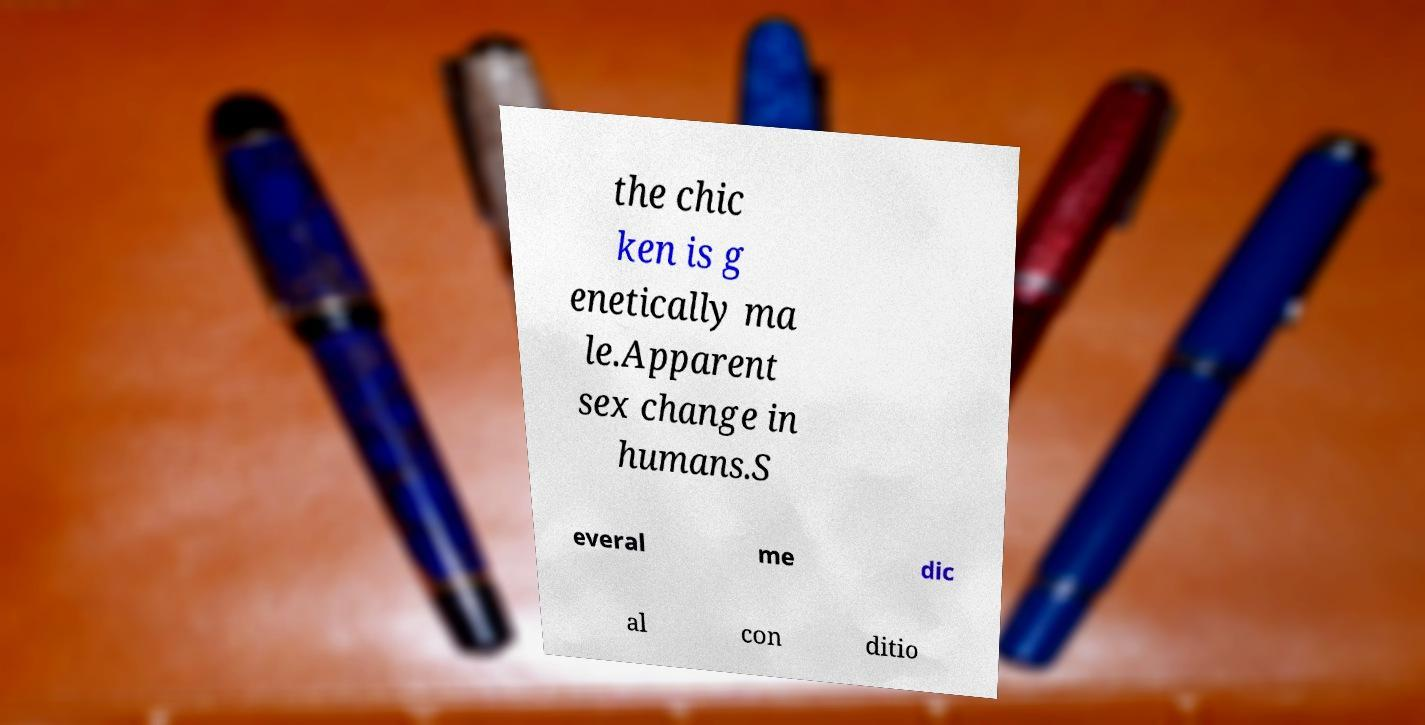There's text embedded in this image that I need extracted. Can you transcribe it verbatim? the chic ken is g enetically ma le.Apparent sex change in humans.S everal me dic al con ditio 